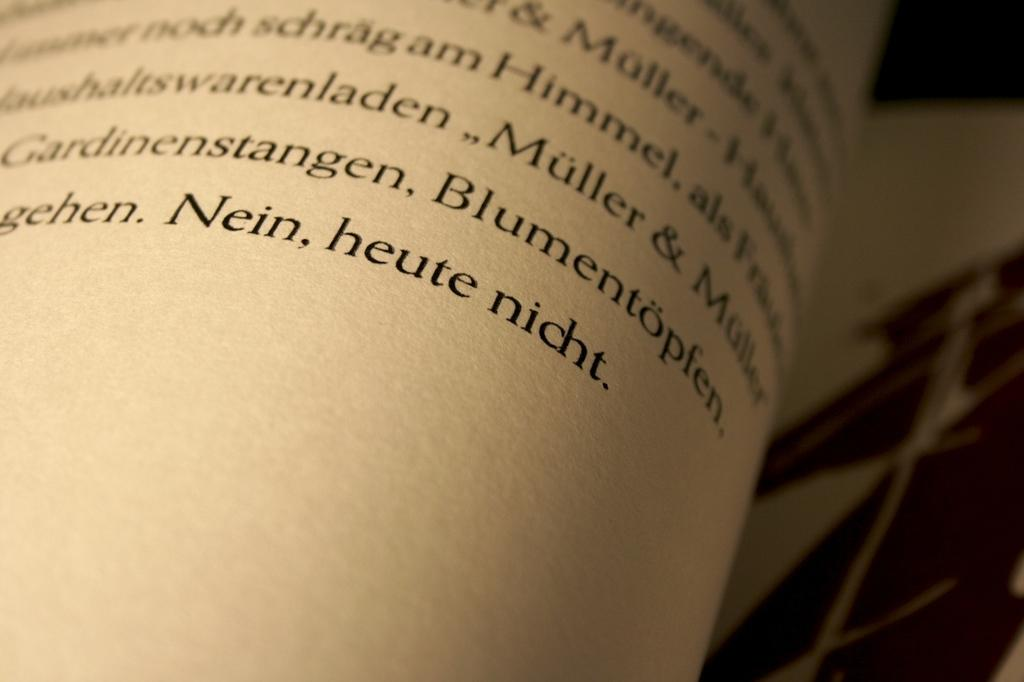<image>
Describe the image concisely. A close up of the page of an open book, the word Nein is visible 